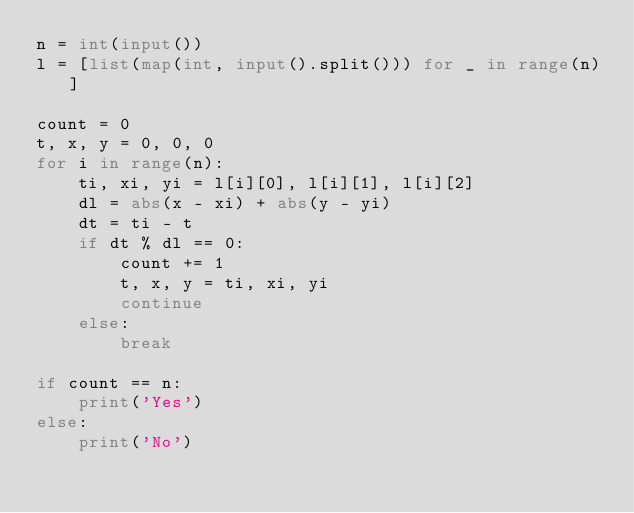<code> <loc_0><loc_0><loc_500><loc_500><_Python_>n = int(input())
l = [list(map(int, input().split())) for _ in range(n)]

count = 0
t, x, y = 0, 0, 0
for i in range(n):
    ti, xi, yi = l[i][0], l[i][1], l[i][2]
    dl = abs(x - xi) + abs(y - yi)
    dt = ti - t
    if dt % dl == 0:
        count += 1
        t, x, y = ti, xi, yi
        continue
    else:
        break

if count == n:
    print('Yes')
else:
    print('No')
</code> 